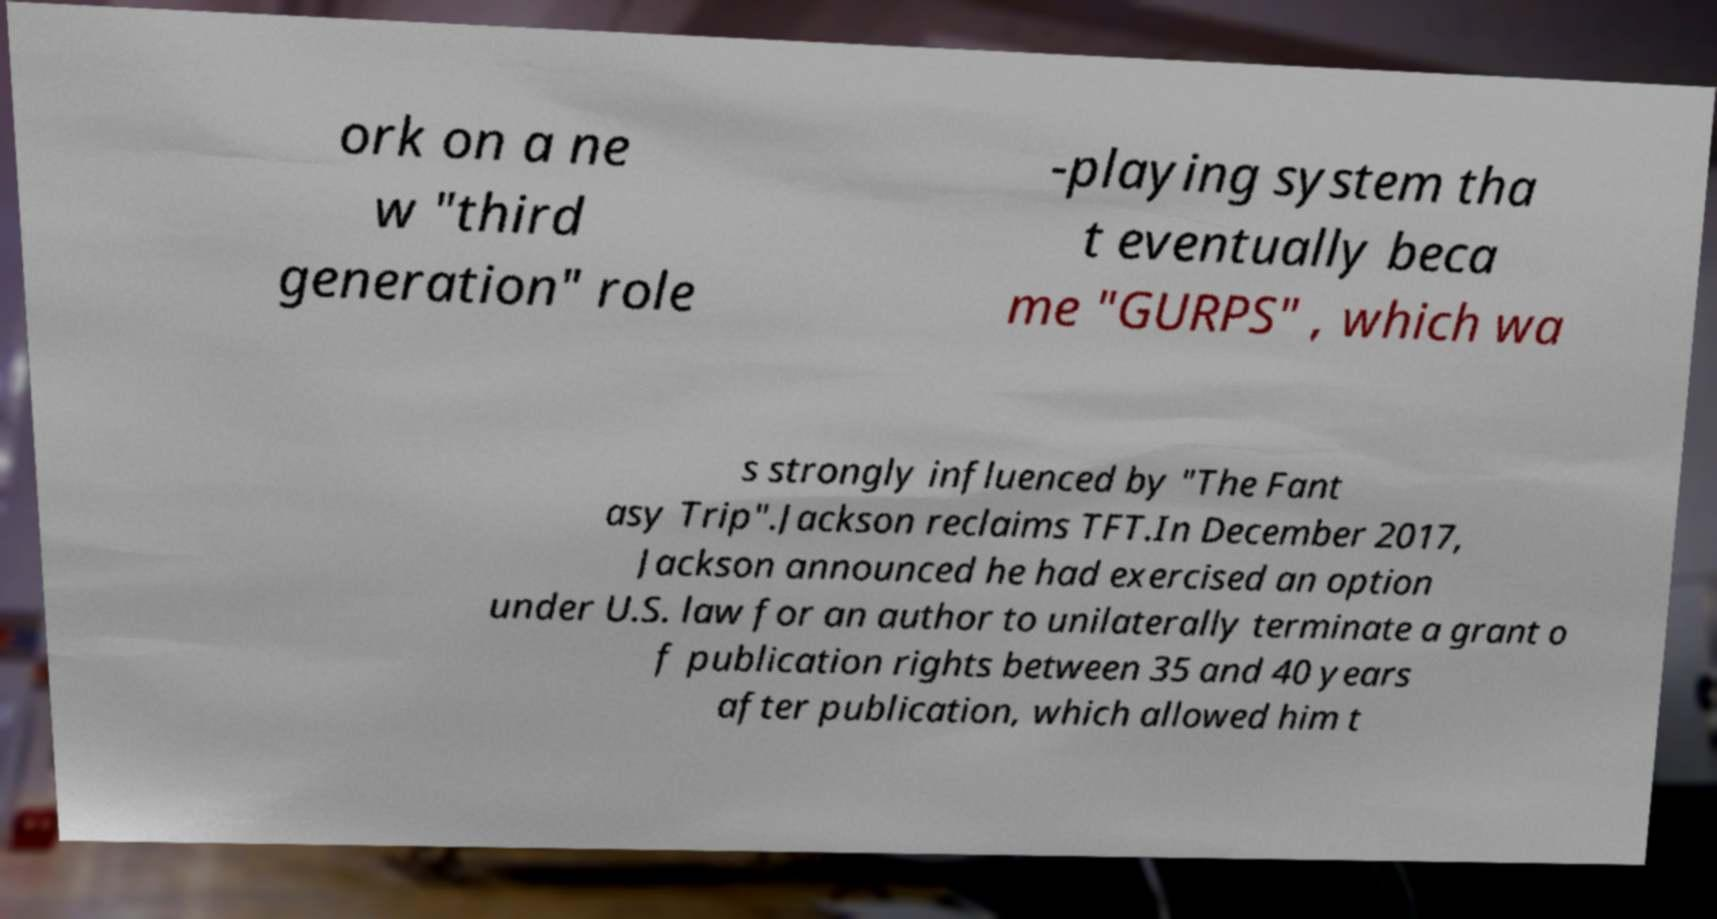I need the written content from this picture converted into text. Can you do that? ork on a ne w "third generation" role -playing system tha t eventually beca me "GURPS" , which wa s strongly influenced by "The Fant asy Trip".Jackson reclaims TFT.In December 2017, Jackson announced he had exercised an option under U.S. law for an author to unilaterally terminate a grant o f publication rights between 35 and 40 years after publication, which allowed him t 